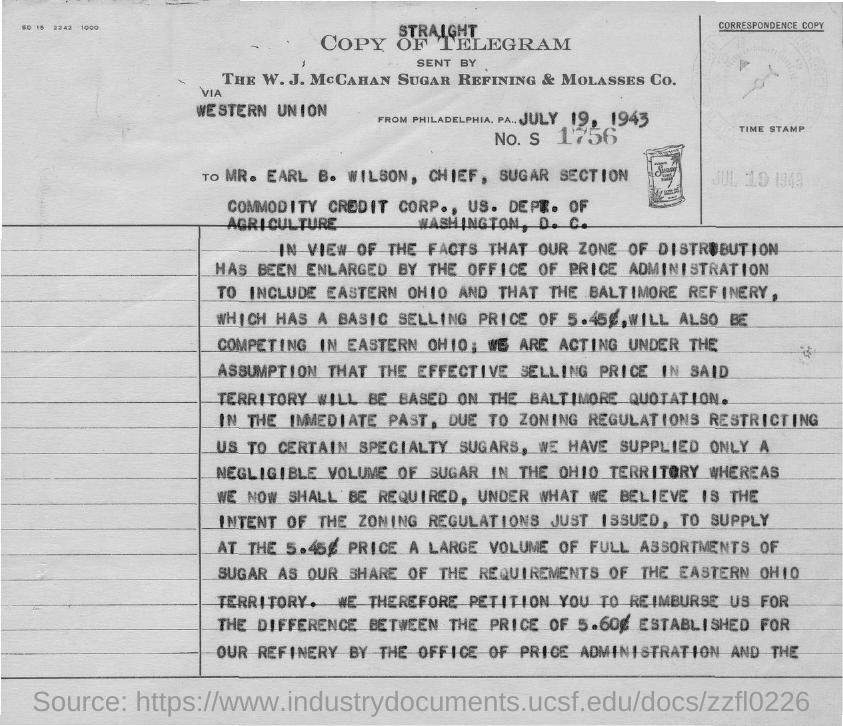What is the date mentioned in the document?
Your response must be concise. JULY 19, 1943. What is the number mentioned in the document?
Your answer should be compact. 1756. 